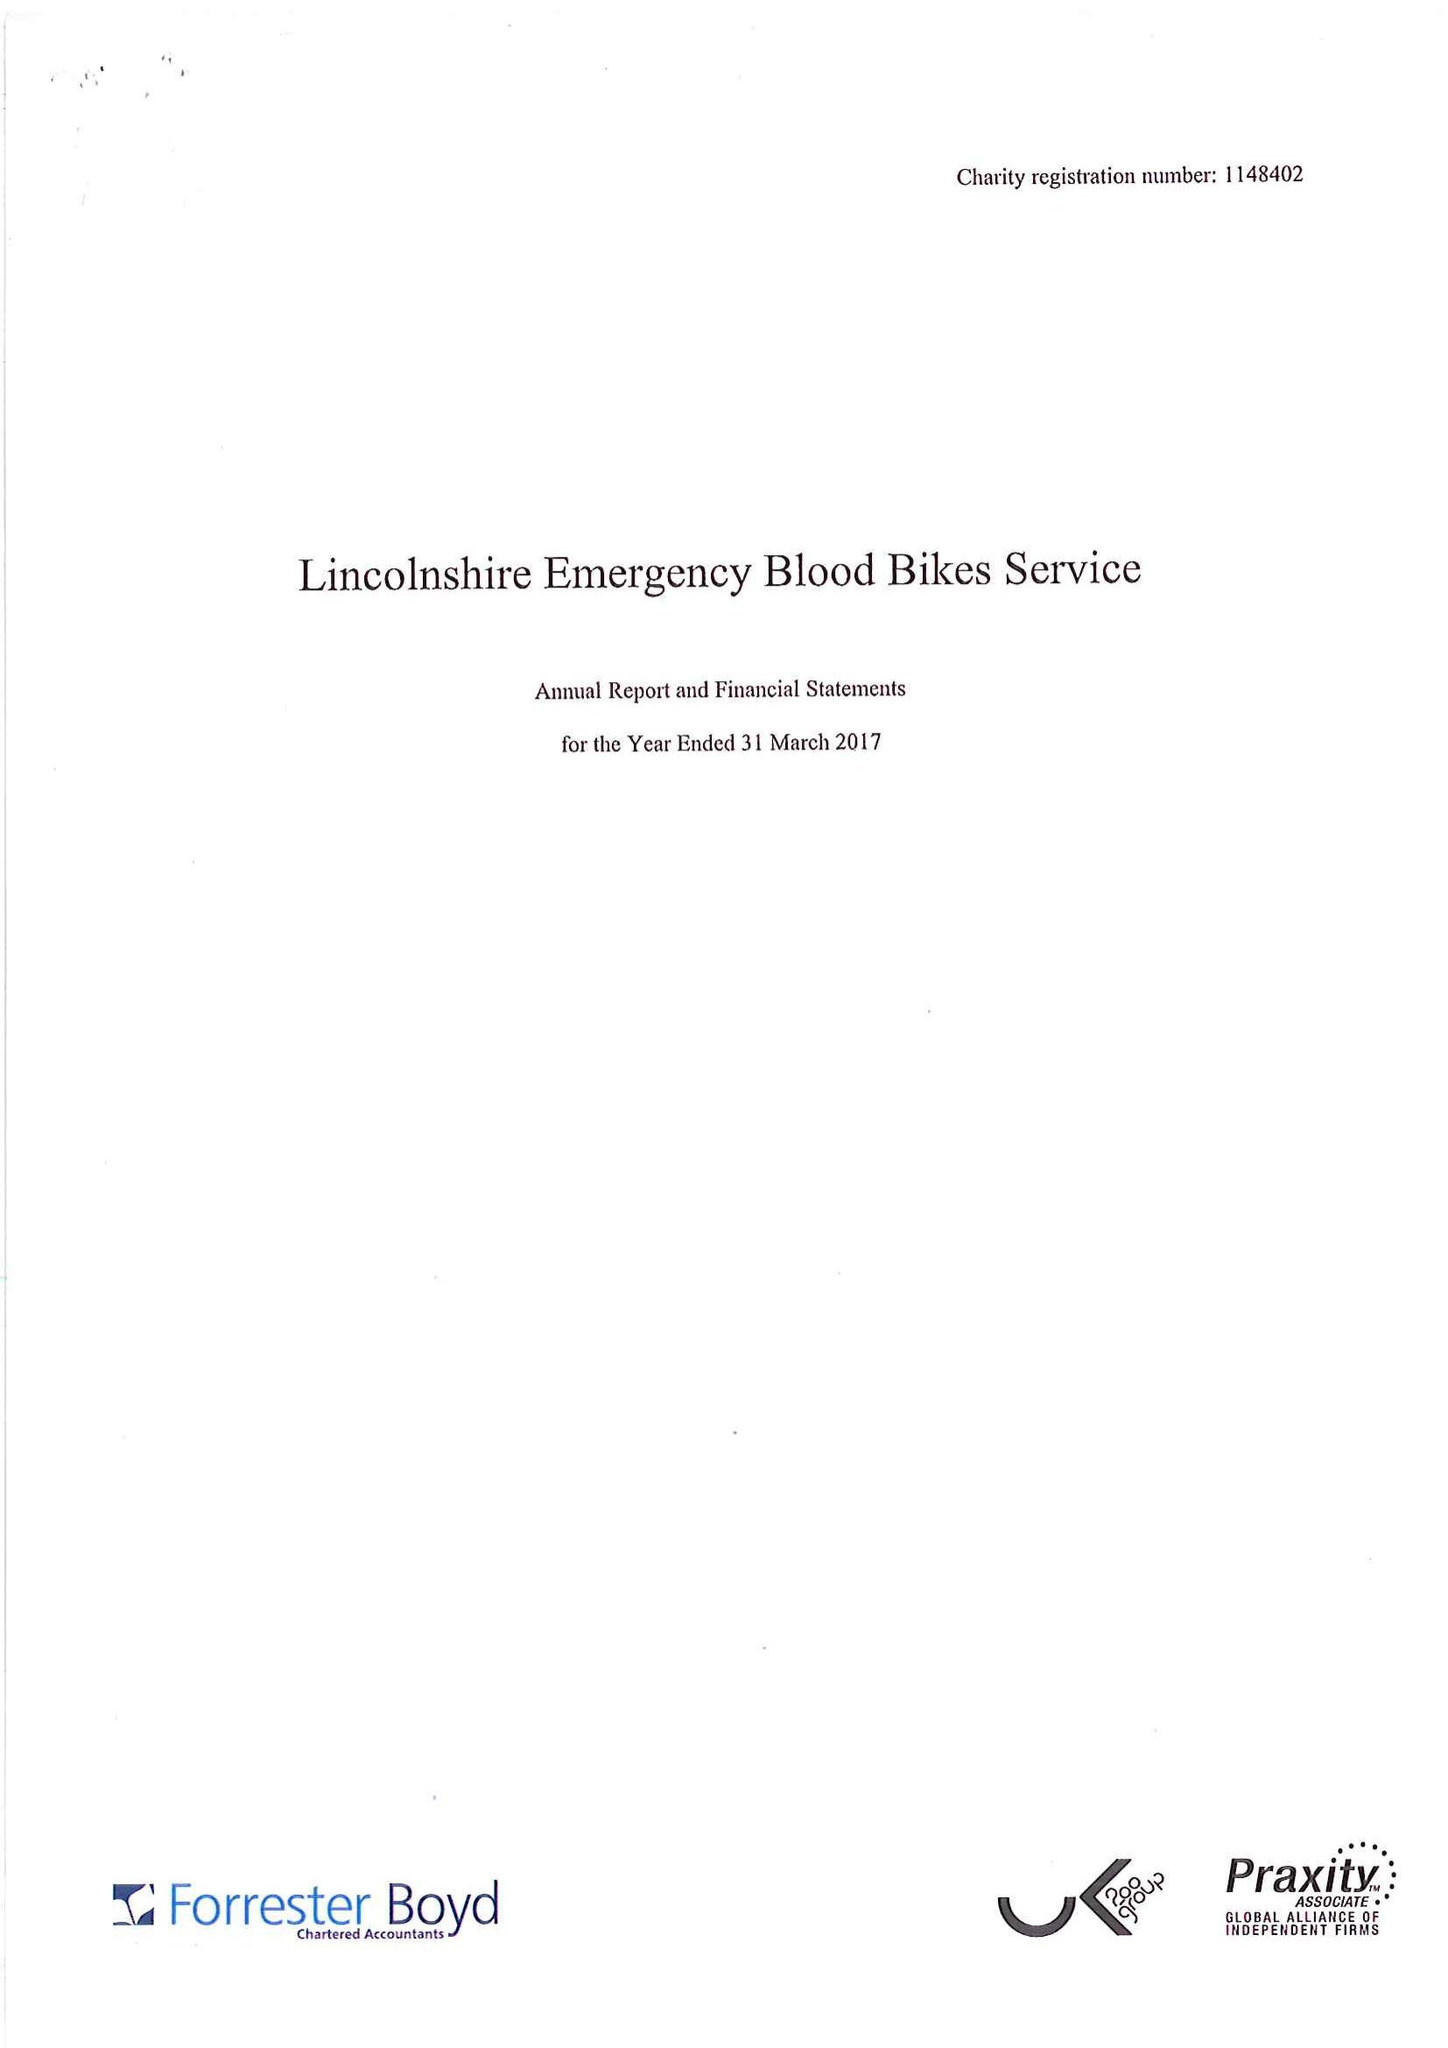What is the value for the charity_name?
Answer the question using a single word or phrase. Lincolnshire Emergency Blood Bikes Service 